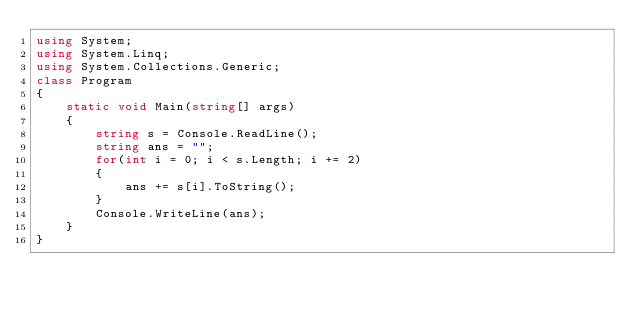<code> <loc_0><loc_0><loc_500><loc_500><_C#_>using System;
using System.Linq;
using System.Collections.Generic;
class Program
{
    static void Main(string[] args)
    {
        string s = Console.ReadLine();
        string ans = "";
        for(int i = 0; i < s.Length; i += 2)
        {
            ans += s[i].ToString();
        }
        Console.WriteLine(ans);
    }
}
</code> 